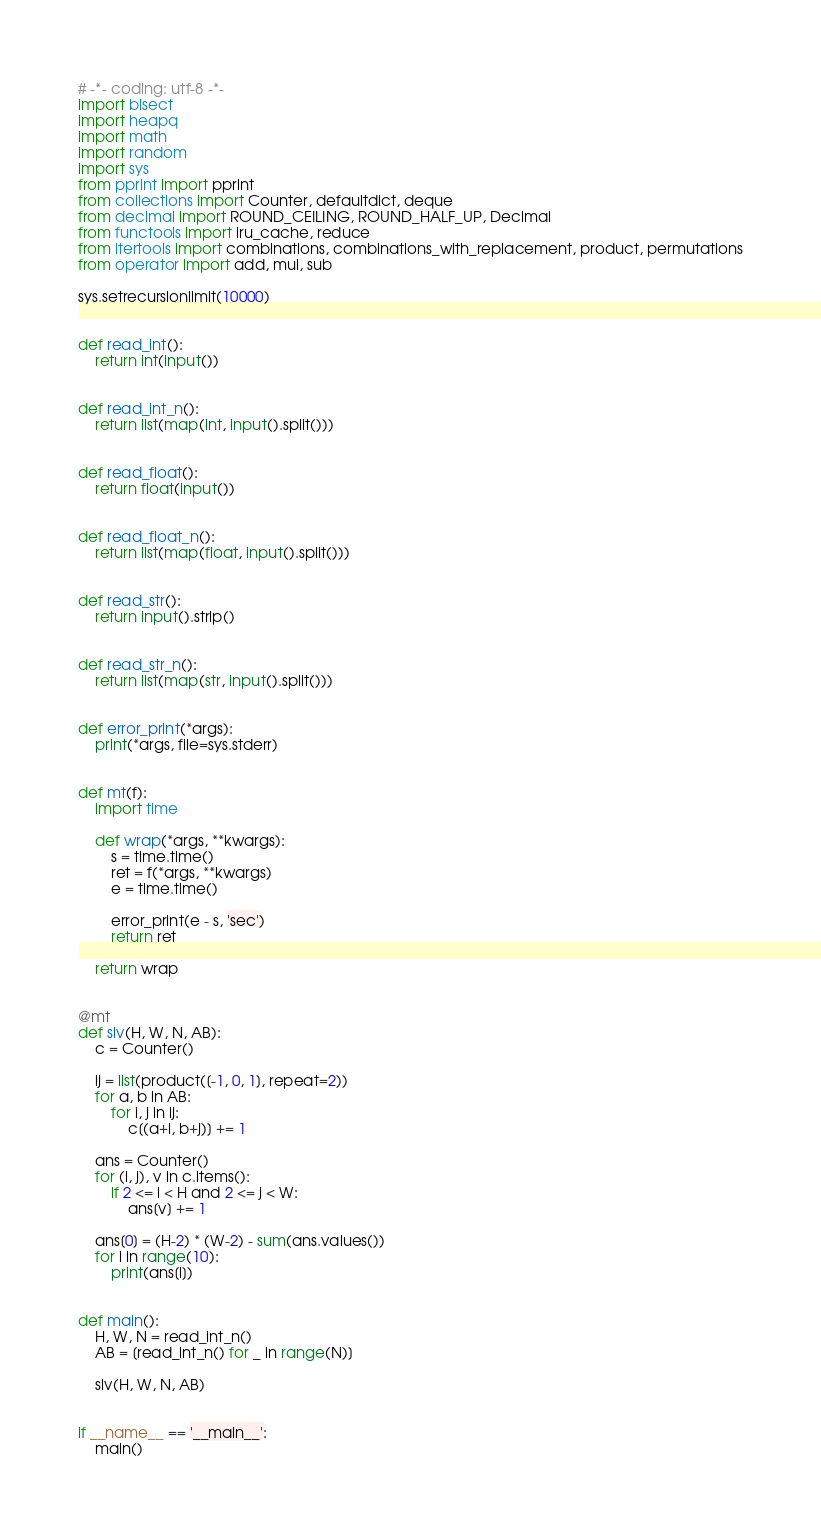<code> <loc_0><loc_0><loc_500><loc_500><_Python_>
# -*- coding: utf-8 -*-
import bisect
import heapq
import math
import random
import sys
from pprint import pprint
from collections import Counter, defaultdict, deque
from decimal import ROUND_CEILING, ROUND_HALF_UP, Decimal
from functools import lru_cache, reduce
from itertools import combinations, combinations_with_replacement, product, permutations
from operator import add, mul, sub

sys.setrecursionlimit(10000)


def read_int():
    return int(input())


def read_int_n():
    return list(map(int, input().split()))


def read_float():
    return float(input())


def read_float_n():
    return list(map(float, input().split()))


def read_str():
    return input().strip()


def read_str_n():
    return list(map(str, input().split()))


def error_print(*args):
    print(*args, file=sys.stderr)


def mt(f):
    import time

    def wrap(*args, **kwargs):
        s = time.time()
        ret = f(*args, **kwargs)
        e = time.time()

        error_print(e - s, 'sec')
        return ret

    return wrap


@mt
def slv(H, W, N, AB):
    c = Counter()

    ij = list(product([-1, 0, 1], repeat=2))
    for a, b in AB:
        for i, j in ij:
            c[(a+i, b+j)] += 1

    ans = Counter()
    for (i, j), v in c.items():
        if 2 <= i < H and 2 <= j < W:
            ans[v] += 1

    ans[0] = (H-2) * (W-2) - sum(ans.values())
    for i in range(10):
        print(ans[i])


def main():
    H, W, N = read_int_n()
    AB = [read_int_n() for _ in range(N)]

    slv(H, W, N, AB)


if __name__ == '__main__':
    main()
</code> 